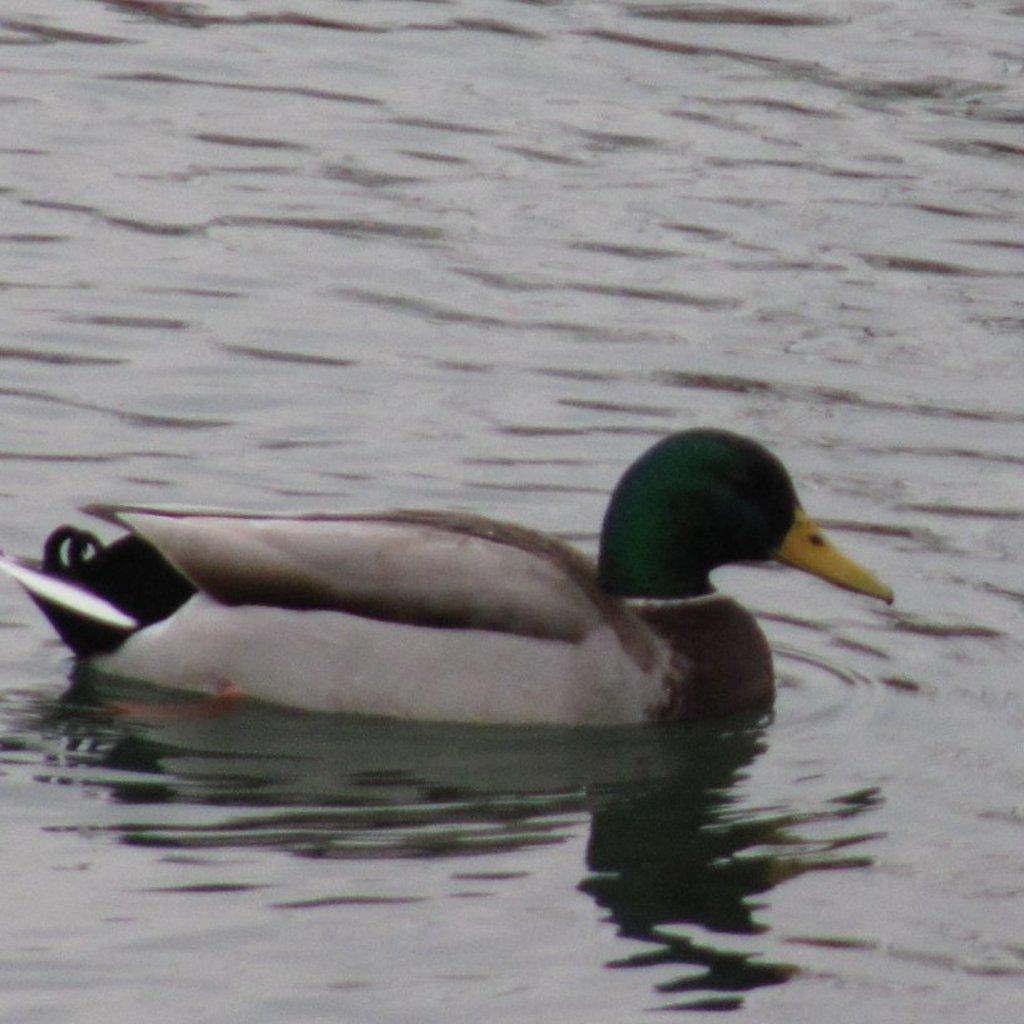What type of animal is in the image? There is a duck in the image. What color is the duck's beak? The duck has a yellow beak. Where is the duck located in the image? The duck is on the water. How many dimes can be seen in the image? There are no dimes present in the image. Is the duck located in a room or a cellar in the image? The image does not show the duck in a room or a cellar; it is on the water. 